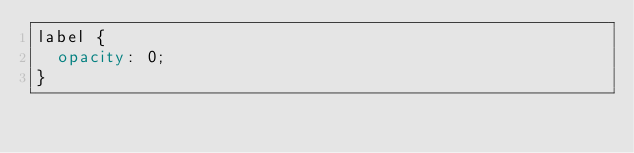Convert code to text. <code><loc_0><loc_0><loc_500><loc_500><_CSS_>label {
  opacity: 0;
}
</code> 